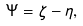Convert formula to latex. <formula><loc_0><loc_0><loc_500><loc_500>\Psi = \zeta - \eta ,</formula> 